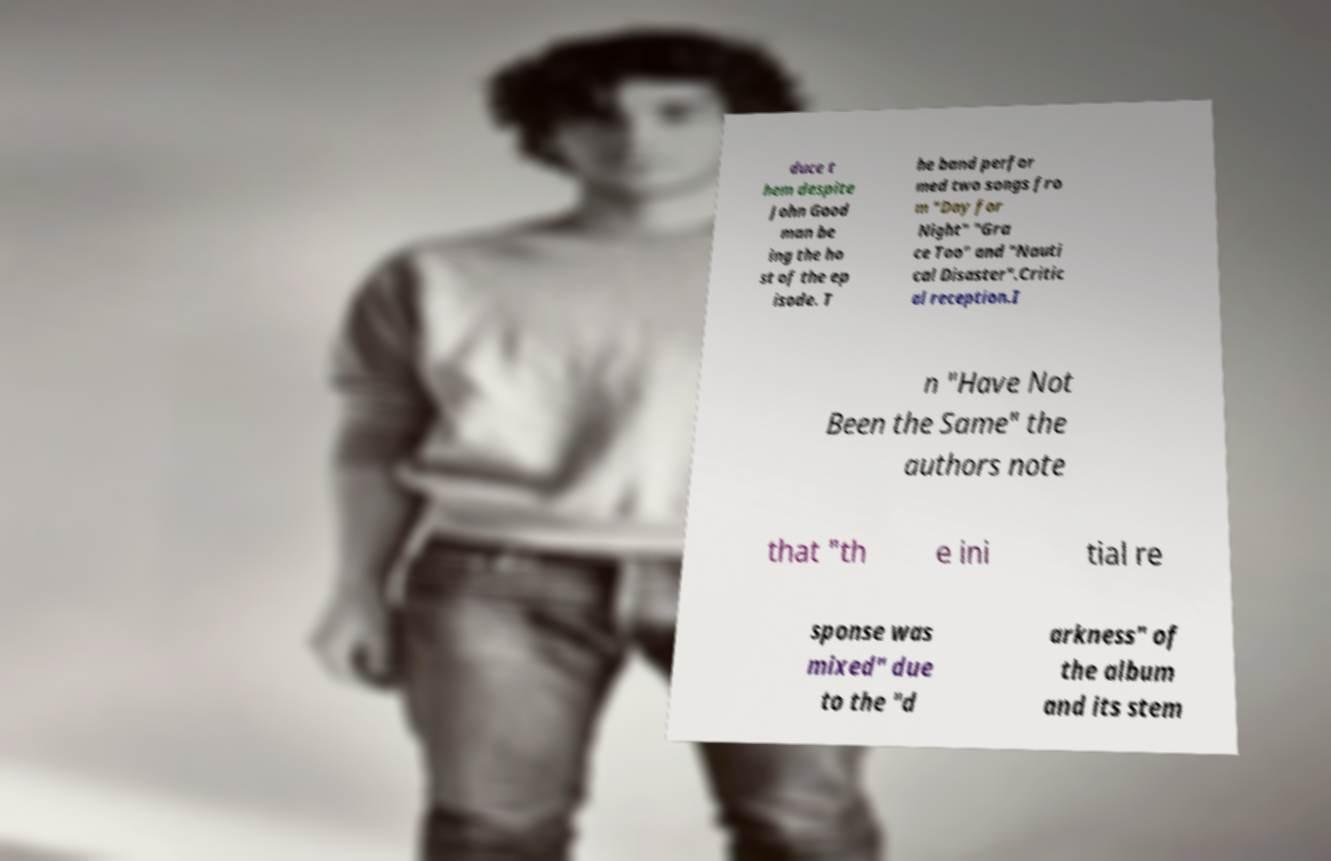Could you assist in decoding the text presented in this image and type it out clearly? duce t hem despite John Good man be ing the ho st of the ep isode. T he band perfor med two songs fro m "Day for Night" "Gra ce Too" and "Nauti cal Disaster".Critic al reception.I n "Have Not Been the Same" the authors note that "th e ini tial re sponse was mixed" due to the "d arkness" of the album and its stem 